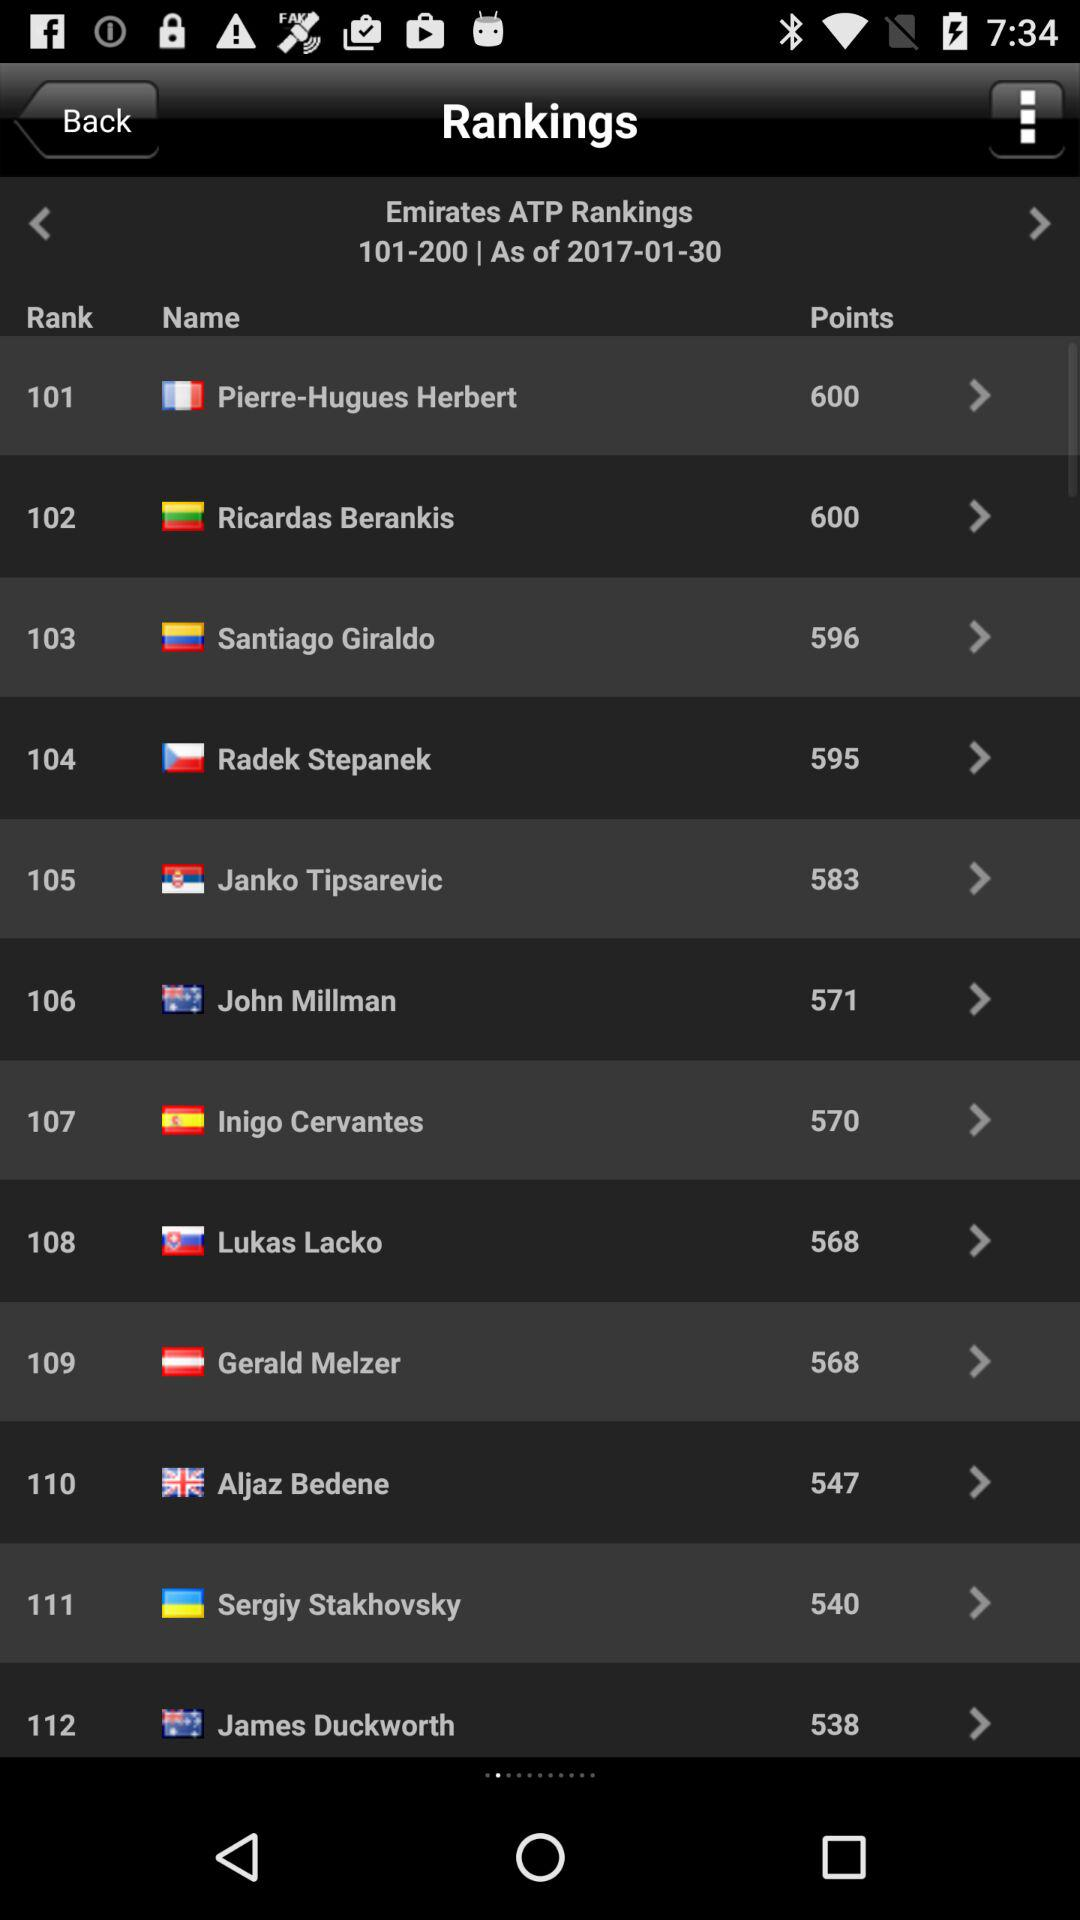What is the rank of Ricardas Berankis? The rank of Ricardas Berankis is 102. 